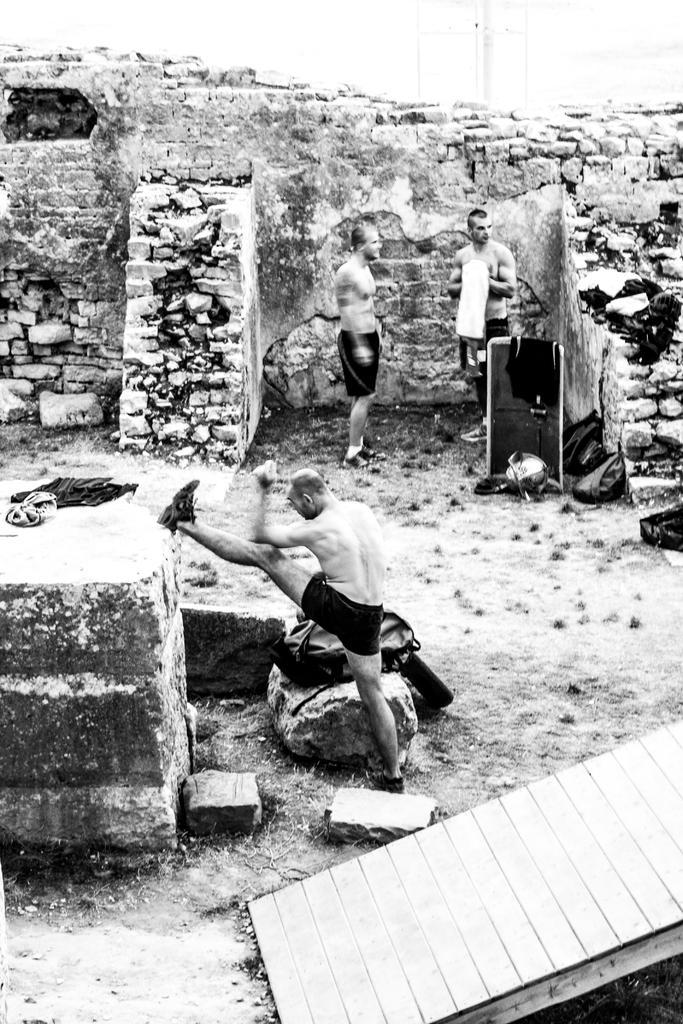In one or two sentences, can you explain what this image depicts? There is a person in a short doing exercise on the ground near a wall and near bag which is on the rock. In the background, there are two persons standing near a brick wall. 